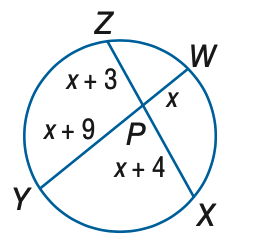Answer the mathemtical geometry problem and directly provide the correct option letter.
Question: Find x. Assume that segments that appear to be tangent are tangent.
Choices: A: 5 B: 6 C: 8 D: 9 B 